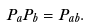Convert formula to latex. <formula><loc_0><loc_0><loc_500><loc_500>P _ { a } P _ { b } = P _ { a b } .</formula> 